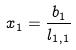Convert formula to latex. <formula><loc_0><loc_0><loc_500><loc_500>x _ { 1 } = \frac { b _ { 1 } } { l _ { 1 , 1 } }</formula> 